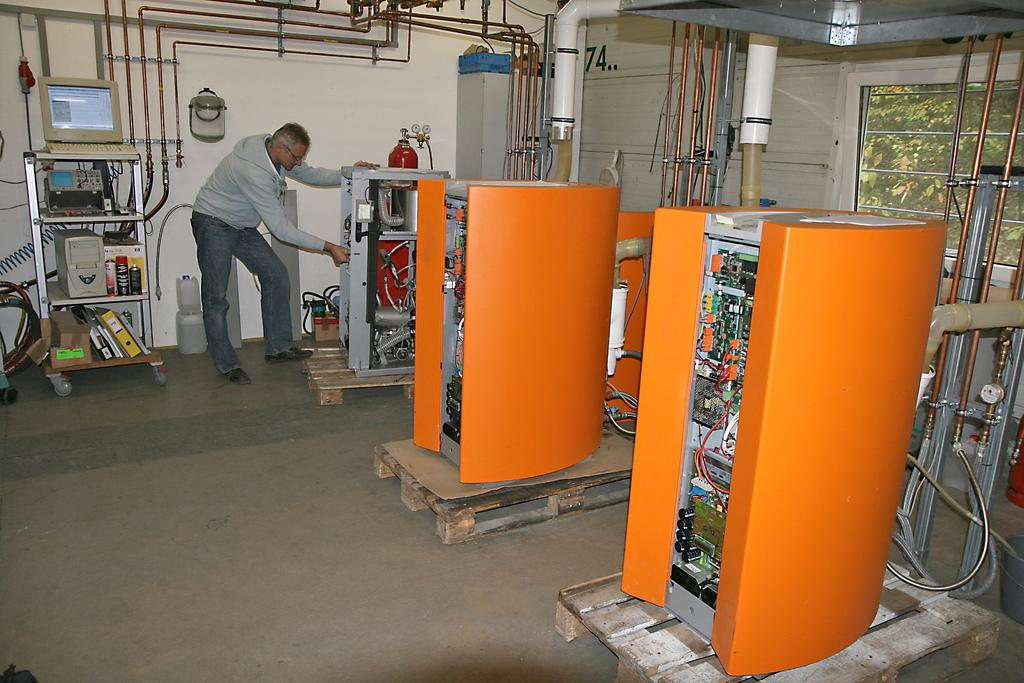<image>
Share a concise interpretation of the image provided. Man working in a server room on floor number 74. 